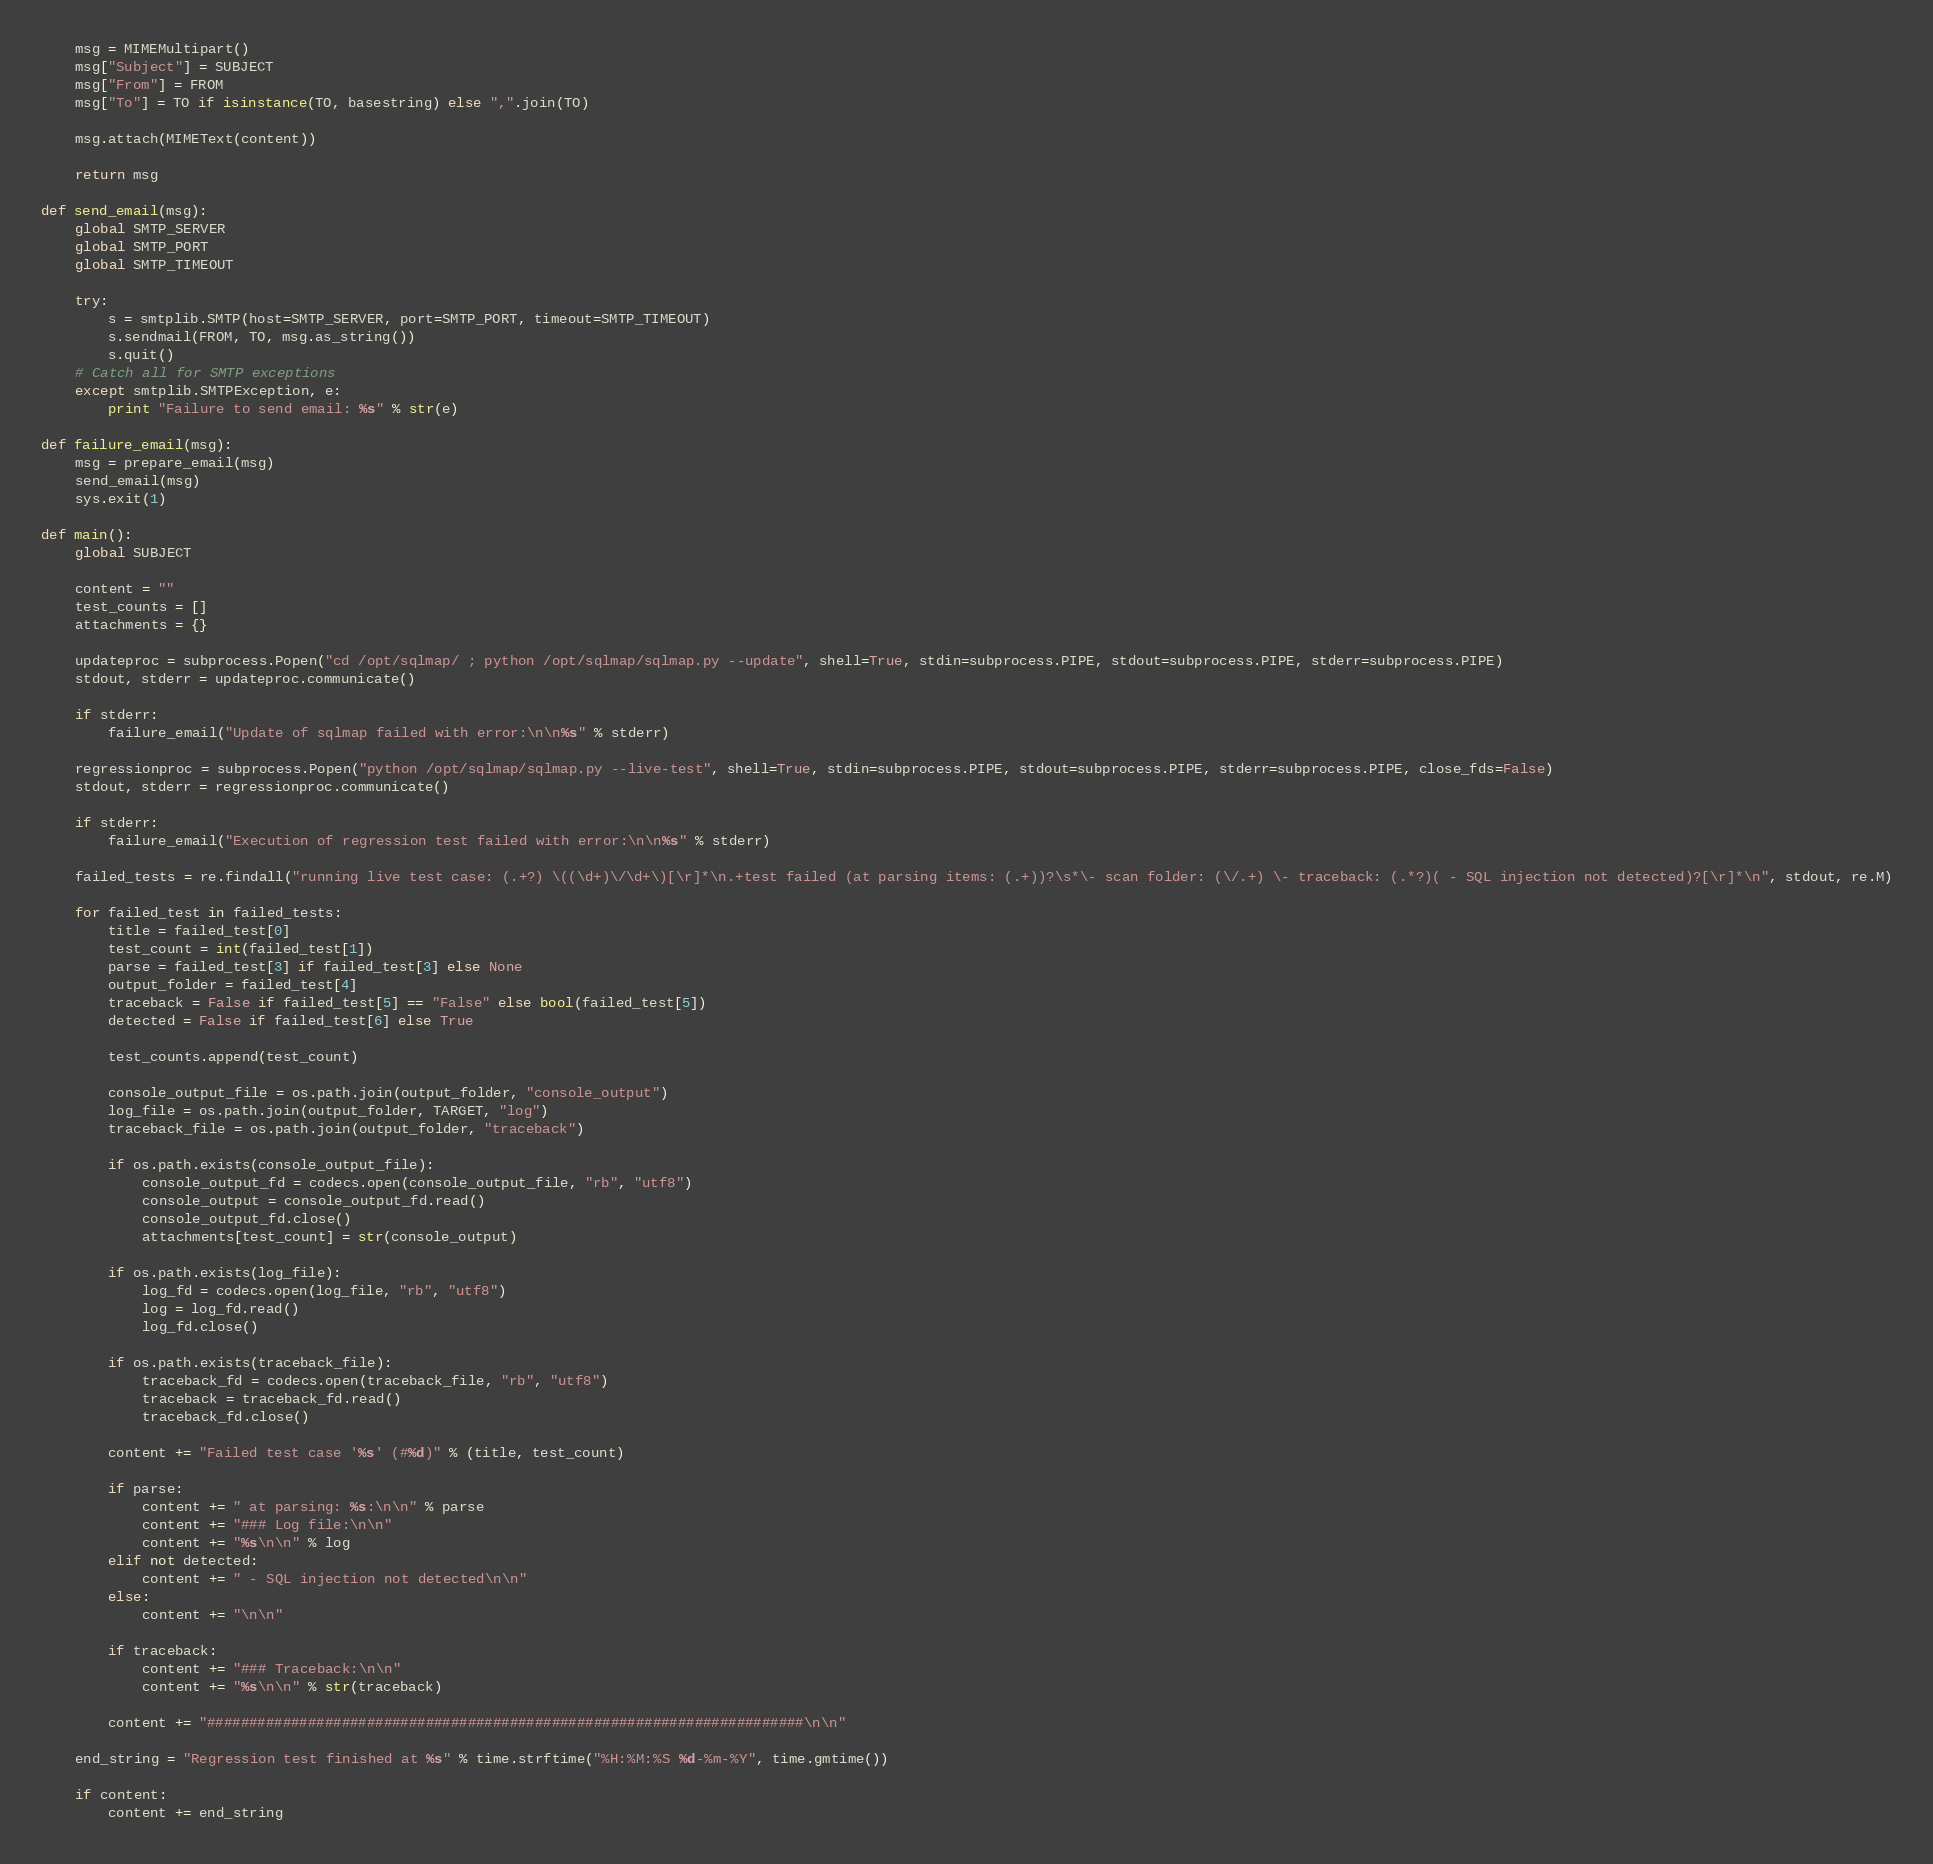<code> <loc_0><loc_0><loc_500><loc_500><_Python_>    msg = MIMEMultipart()
    msg["Subject"] = SUBJECT
    msg["From"] = FROM
    msg["To"] = TO if isinstance(TO, basestring) else ",".join(TO)

    msg.attach(MIMEText(content))

    return msg

def send_email(msg):
    global SMTP_SERVER
    global SMTP_PORT
    global SMTP_TIMEOUT

    try:
        s = smtplib.SMTP(host=SMTP_SERVER, port=SMTP_PORT, timeout=SMTP_TIMEOUT)
        s.sendmail(FROM, TO, msg.as_string())
        s.quit()
    # Catch all for SMTP exceptions
    except smtplib.SMTPException, e:
        print "Failure to send email: %s" % str(e)

def failure_email(msg):
    msg = prepare_email(msg)
    send_email(msg)
    sys.exit(1)

def main():
    global SUBJECT

    content = ""
    test_counts = []
    attachments = {}

    updateproc = subprocess.Popen("cd /opt/sqlmap/ ; python /opt/sqlmap/sqlmap.py --update", shell=True, stdin=subprocess.PIPE, stdout=subprocess.PIPE, stderr=subprocess.PIPE)
    stdout, stderr = updateproc.communicate()

    if stderr:
        failure_email("Update of sqlmap failed with error:\n\n%s" % stderr)

    regressionproc = subprocess.Popen("python /opt/sqlmap/sqlmap.py --live-test", shell=True, stdin=subprocess.PIPE, stdout=subprocess.PIPE, stderr=subprocess.PIPE, close_fds=False)
    stdout, stderr = regressionproc.communicate()

    if stderr:
        failure_email("Execution of regression test failed with error:\n\n%s" % stderr)

    failed_tests = re.findall("running live test case: (.+?) \((\d+)\/\d+\)[\r]*\n.+test failed (at parsing items: (.+))?\s*\- scan folder: (\/.+) \- traceback: (.*?)( - SQL injection not detected)?[\r]*\n", stdout, re.M)

    for failed_test in failed_tests:
        title = failed_test[0]
        test_count = int(failed_test[1])
        parse = failed_test[3] if failed_test[3] else None
        output_folder = failed_test[4]
        traceback = False if failed_test[5] == "False" else bool(failed_test[5])
        detected = False if failed_test[6] else True

        test_counts.append(test_count)

        console_output_file = os.path.join(output_folder, "console_output")
        log_file = os.path.join(output_folder, TARGET, "log")
        traceback_file = os.path.join(output_folder, "traceback")

        if os.path.exists(console_output_file):
            console_output_fd = codecs.open(console_output_file, "rb", "utf8")
            console_output = console_output_fd.read()
            console_output_fd.close()
            attachments[test_count] = str(console_output)

        if os.path.exists(log_file):
            log_fd = codecs.open(log_file, "rb", "utf8")
            log = log_fd.read()
            log_fd.close()

        if os.path.exists(traceback_file):
            traceback_fd = codecs.open(traceback_file, "rb", "utf8")
            traceback = traceback_fd.read()
            traceback_fd.close()

        content += "Failed test case '%s' (#%d)" % (title, test_count)

        if parse:
            content += " at parsing: %s:\n\n" % parse
            content += "### Log file:\n\n"
            content += "%s\n\n" % log
        elif not detected:
            content += " - SQL injection not detected\n\n"
        else:
            content += "\n\n"

        if traceback:
            content += "### Traceback:\n\n"
            content += "%s\n\n" % str(traceback)

        content += "#######################################################################\n\n"

    end_string = "Regression test finished at %s" % time.strftime("%H:%M:%S %d-%m-%Y", time.gmtime())

    if content:
        content += end_string</code> 